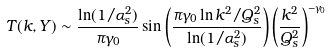<formula> <loc_0><loc_0><loc_500><loc_500>T ( k , Y ) \sim \frac { \ln ( 1 / \alpha _ { s } ^ { 2 } ) } { \pi \gamma _ { 0 } } \sin \left ( \frac { \pi \gamma _ { 0 } \ln k ^ { 2 } / Q _ { s } ^ { 2 } } { \ln ( 1 / \alpha _ { s } ^ { 2 } ) } \right ) \left ( \frac { k ^ { 2 } } { Q _ { s } ^ { 2 } } \right ) ^ { - \gamma _ { 0 } }</formula> 